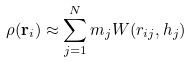Convert formula to latex. <formula><loc_0><loc_0><loc_500><loc_500>\rho ( { \mathbf r _ { i } } ) \approx \sum _ { j = 1 } ^ { N } m _ { j } W ( r _ { i j } , h _ { j } )</formula> 